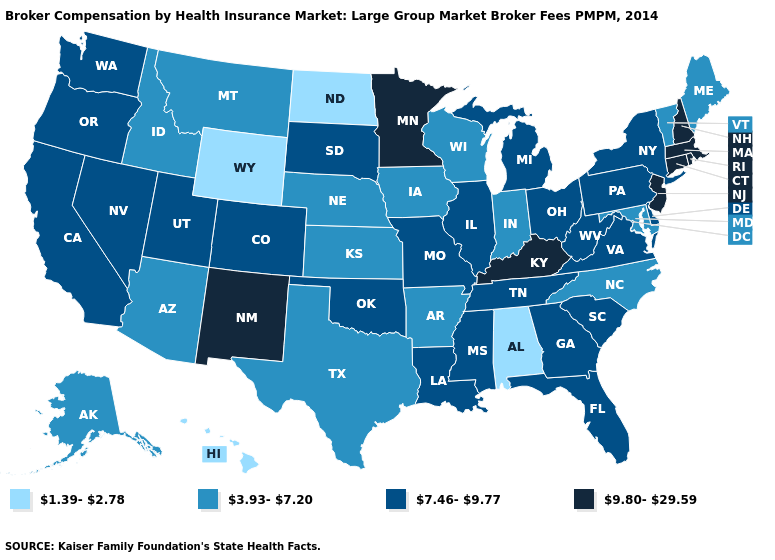Which states have the lowest value in the Northeast?
Answer briefly. Maine, Vermont. What is the value of Michigan?
Quick response, please. 7.46-9.77. Name the states that have a value in the range 3.93-7.20?
Short answer required. Alaska, Arizona, Arkansas, Idaho, Indiana, Iowa, Kansas, Maine, Maryland, Montana, Nebraska, North Carolina, Texas, Vermont, Wisconsin. Which states hav the highest value in the MidWest?
Concise answer only. Minnesota. Does the first symbol in the legend represent the smallest category?
Answer briefly. Yes. Among the states that border Georgia , does Alabama have the lowest value?
Quick response, please. Yes. Name the states that have a value in the range 3.93-7.20?
Keep it brief. Alaska, Arizona, Arkansas, Idaho, Indiana, Iowa, Kansas, Maine, Maryland, Montana, Nebraska, North Carolina, Texas, Vermont, Wisconsin. Does Tennessee have the highest value in the USA?
Keep it brief. No. What is the value of Vermont?
Short answer required. 3.93-7.20. Name the states that have a value in the range 1.39-2.78?
Short answer required. Alabama, Hawaii, North Dakota, Wyoming. Name the states that have a value in the range 3.93-7.20?
Be succinct. Alaska, Arizona, Arkansas, Idaho, Indiana, Iowa, Kansas, Maine, Maryland, Montana, Nebraska, North Carolina, Texas, Vermont, Wisconsin. What is the value of New York?
Keep it brief. 7.46-9.77. Does the first symbol in the legend represent the smallest category?
Keep it brief. Yes. What is the value of Texas?
Quick response, please. 3.93-7.20. Which states hav the highest value in the Northeast?
Write a very short answer. Connecticut, Massachusetts, New Hampshire, New Jersey, Rhode Island. 